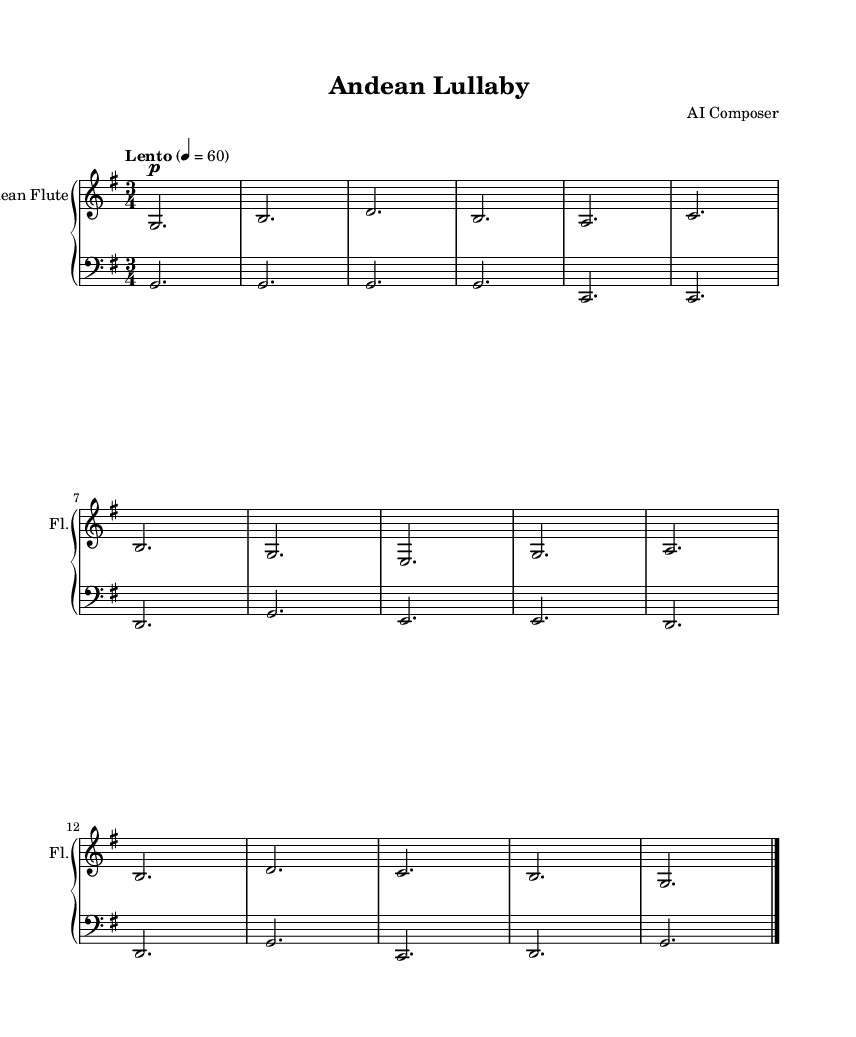What is the key signature of this music? The key signature is G major, which has one sharp (F#). You can determine this by identifying the key signature shown at the beginning of the score, which indicates a major scale with one sharp.
Answer: G major What is the time signature of the piece? The time signature is 3/4, indicated at the beginning of the score. This means there are three beats per measure and the quarter note gets one beat.
Answer: 3/4 What is the tempo marking of the music? The tempo marking is "Lento," meaning it should be played slowly. This is specified in the tempo instruction found at the beginning of the piece.
Answer: Lento How many measures are in the melody? There are 14 measures in the melody. You can count the vertical lines (bar lines) that separate each measure to determine the total number.
Answer: 14 What instrument is this music composed for? The music is composed for the Andean flute, which is indicated in the instrument name at the top of the upper staff.
Answer: Andean flute What type of musical form does this piece represent? The piece represents a lullaby form, typically characterized by soothing melodies intended for children, as indicated by its title "Andean Lullaby."
Answer: Lullaby What is the highest note in the melody? The highest note in the melody is D. You can identify this by looking through the melody part and finding the note with the highest pitch.
Answer: D 